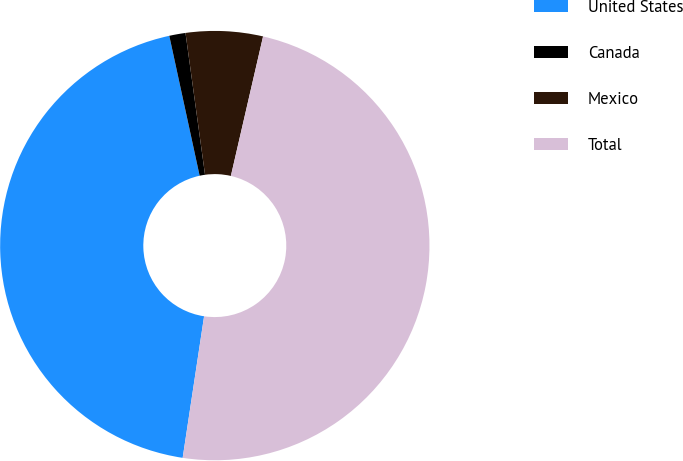<chart> <loc_0><loc_0><loc_500><loc_500><pie_chart><fcel>United States<fcel>Canada<fcel>Mexico<fcel>Total<nl><fcel>44.21%<fcel>1.22%<fcel>5.79%<fcel>48.78%<nl></chart> 